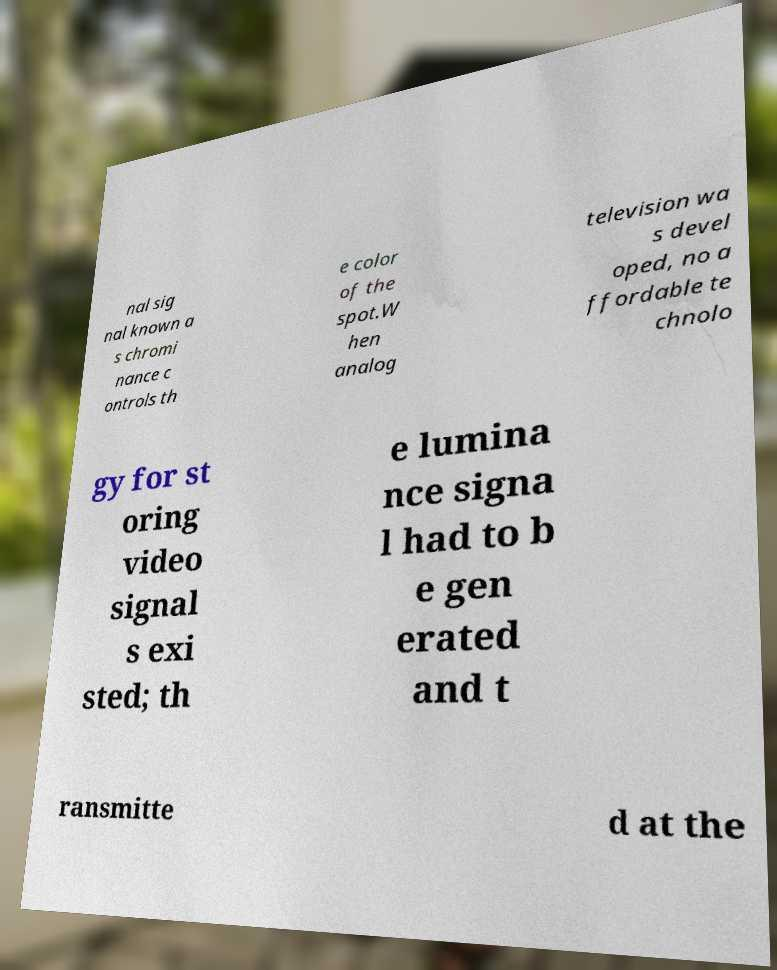What messages or text are displayed in this image? I need them in a readable, typed format. nal sig nal known a s chromi nance c ontrols th e color of the spot.W hen analog television wa s devel oped, no a ffordable te chnolo gy for st oring video signal s exi sted; th e lumina nce signa l had to b e gen erated and t ransmitte d at the 